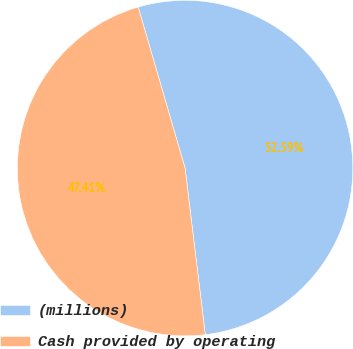Convert chart. <chart><loc_0><loc_0><loc_500><loc_500><pie_chart><fcel>(millions)<fcel>Cash provided by operating<nl><fcel>52.59%<fcel>47.41%<nl></chart> 